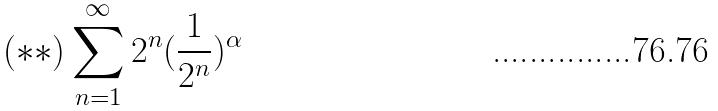Convert formula to latex. <formula><loc_0><loc_0><loc_500><loc_500>( * * ) \sum _ { n = 1 } ^ { \infty } 2 ^ { n } ( \frac { 1 } { 2 ^ { n } } ) ^ { \alpha }</formula> 